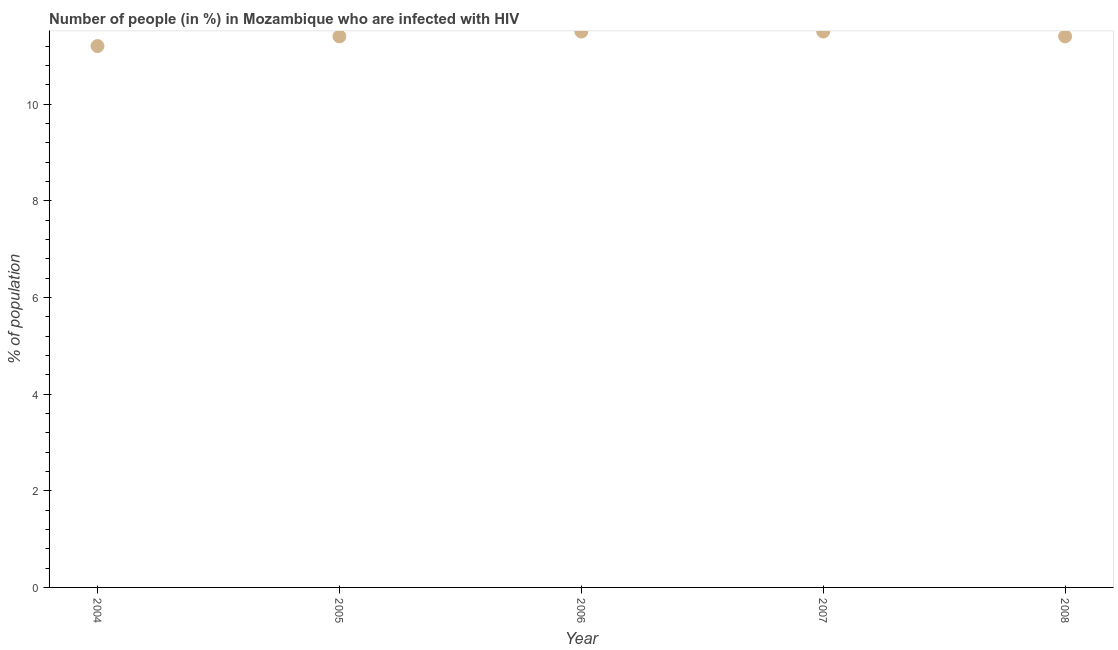What is the number of people infected with hiv in 2007?
Keep it short and to the point. 11.5. Across all years, what is the maximum number of people infected with hiv?
Your response must be concise. 11.5. Across all years, what is the minimum number of people infected with hiv?
Offer a terse response. 11.2. In which year was the number of people infected with hiv maximum?
Offer a very short reply. 2006. In which year was the number of people infected with hiv minimum?
Keep it short and to the point. 2004. What is the difference between the number of people infected with hiv in 2006 and 2008?
Give a very brief answer. 0.1. What is the average number of people infected with hiv per year?
Offer a terse response. 11.4. What is the median number of people infected with hiv?
Provide a short and direct response. 11.4. What is the ratio of the number of people infected with hiv in 2006 to that in 2008?
Your response must be concise. 1.01. Is the number of people infected with hiv in 2005 less than that in 2008?
Make the answer very short. No. Is the difference between the number of people infected with hiv in 2006 and 2007 greater than the difference between any two years?
Offer a terse response. No. What is the difference between the highest and the second highest number of people infected with hiv?
Give a very brief answer. 0. Is the sum of the number of people infected with hiv in 2005 and 2007 greater than the maximum number of people infected with hiv across all years?
Make the answer very short. Yes. What is the difference between the highest and the lowest number of people infected with hiv?
Give a very brief answer. 0.3. Does the number of people infected with hiv monotonically increase over the years?
Your answer should be very brief. No. How many dotlines are there?
Make the answer very short. 1. How many years are there in the graph?
Offer a terse response. 5. What is the difference between two consecutive major ticks on the Y-axis?
Keep it short and to the point. 2. Does the graph contain grids?
Provide a succinct answer. No. What is the title of the graph?
Provide a short and direct response. Number of people (in %) in Mozambique who are infected with HIV. What is the label or title of the X-axis?
Provide a short and direct response. Year. What is the label or title of the Y-axis?
Offer a terse response. % of population. What is the % of population in 2004?
Ensure brevity in your answer.  11.2. What is the % of population in 2005?
Provide a short and direct response. 11.4. What is the % of population in 2007?
Give a very brief answer. 11.5. What is the difference between the % of population in 2004 and 2006?
Make the answer very short. -0.3. What is the difference between the % of population in 2004 and 2008?
Provide a short and direct response. -0.2. What is the difference between the % of population in 2005 and 2006?
Keep it short and to the point. -0.1. What is the difference between the % of population in 2006 and 2008?
Give a very brief answer. 0.1. What is the difference between the % of population in 2007 and 2008?
Provide a short and direct response. 0.1. What is the ratio of the % of population in 2004 to that in 2005?
Your answer should be very brief. 0.98. What is the ratio of the % of population in 2004 to that in 2006?
Give a very brief answer. 0.97. What is the ratio of the % of population in 2004 to that in 2008?
Your response must be concise. 0.98. What is the ratio of the % of population in 2005 to that in 2007?
Your answer should be very brief. 0.99. What is the ratio of the % of population in 2005 to that in 2008?
Provide a short and direct response. 1. What is the ratio of the % of population in 2006 to that in 2008?
Provide a short and direct response. 1.01. What is the ratio of the % of population in 2007 to that in 2008?
Your answer should be very brief. 1.01. 